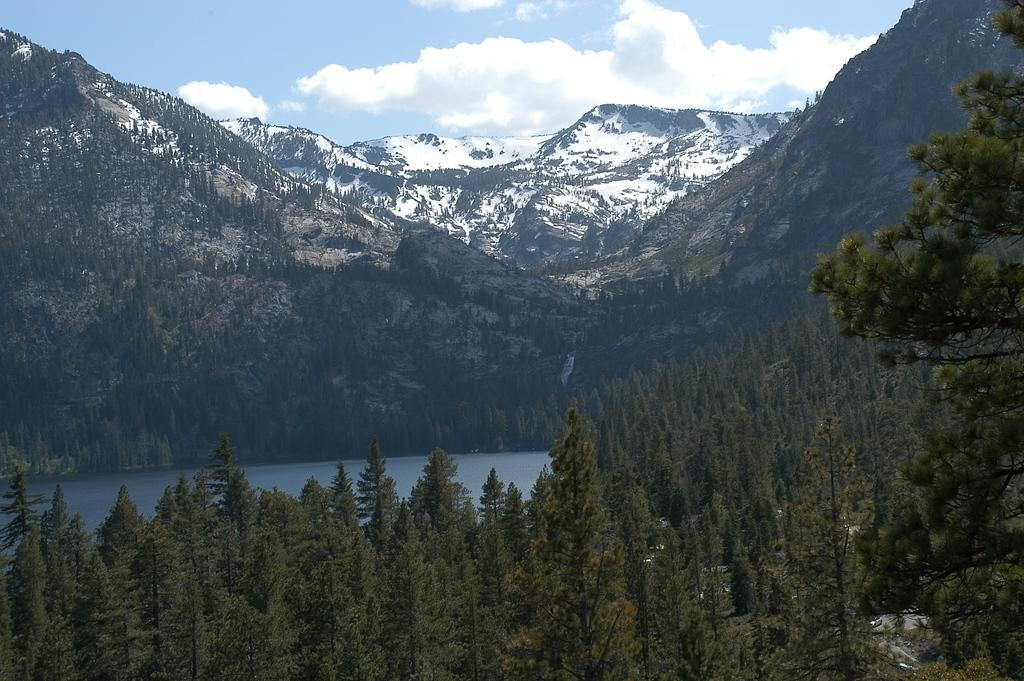What type of vegetation can be seen in the image? There are trees in the image. What is located behind the trees? There is a river behind the trees. What is visible behind the river? There are mountains behind the river. What can be seen in the sky at the top of the image? Clouds are visible in the sky at the top of the image. What type of riddle can be solved by looking at the hour on the clock in the image? There is no clock or riddle present in the image. Can you tell me how many goldfish are swimming in the river in the image? There are no goldfish visible in the river in the image. 